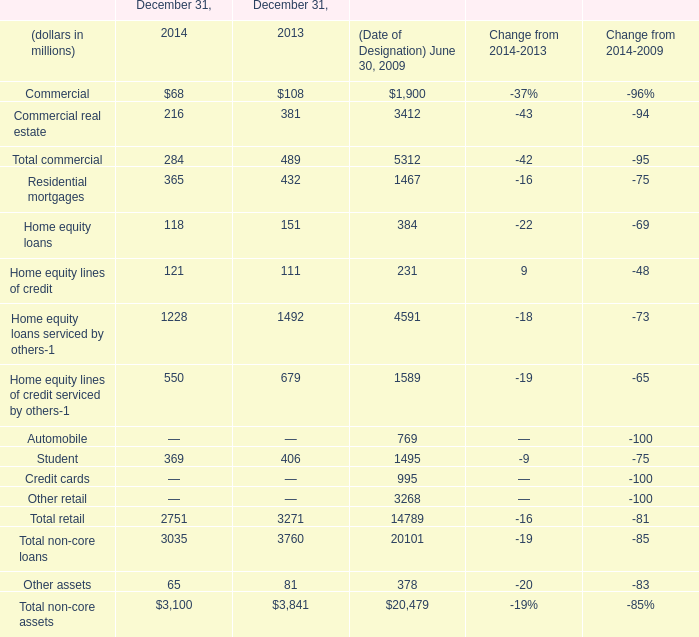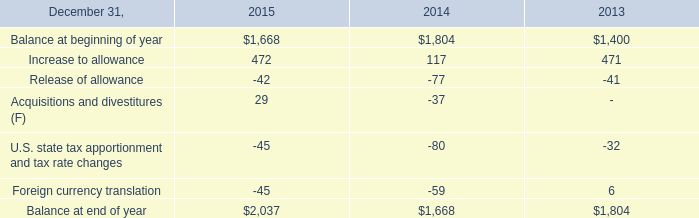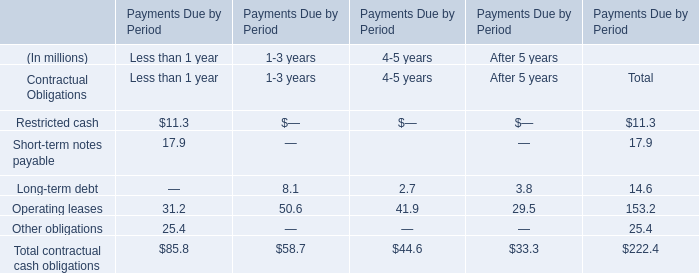What's the total value of all element that are smaller than 300 in 2014? (in million) 
Computations: (((((68 + 216) + 284) + 118) + 121) + 65)
Answer: 872.0. 